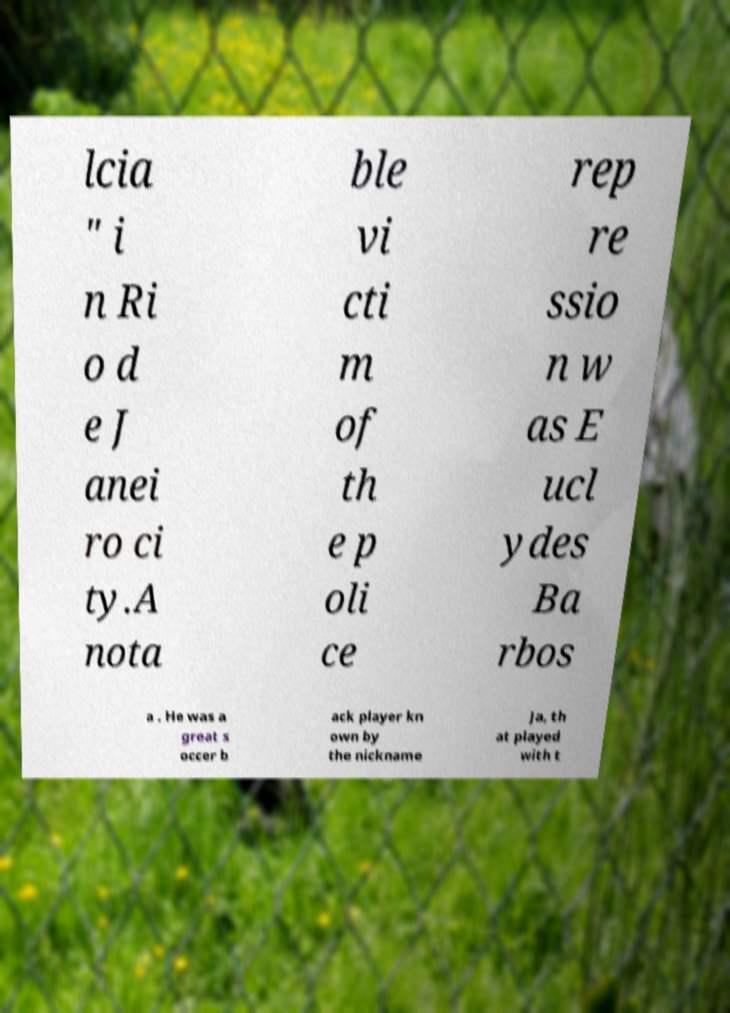Can you read and provide the text displayed in the image?This photo seems to have some interesting text. Can you extract and type it out for me? lcia " i n Ri o d e J anei ro ci ty.A nota ble vi cti m of th e p oli ce rep re ssio n w as E ucl ydes Ba rbos a . He was a great s occer b ack player kn own by the nickname Ja, th at played with t 